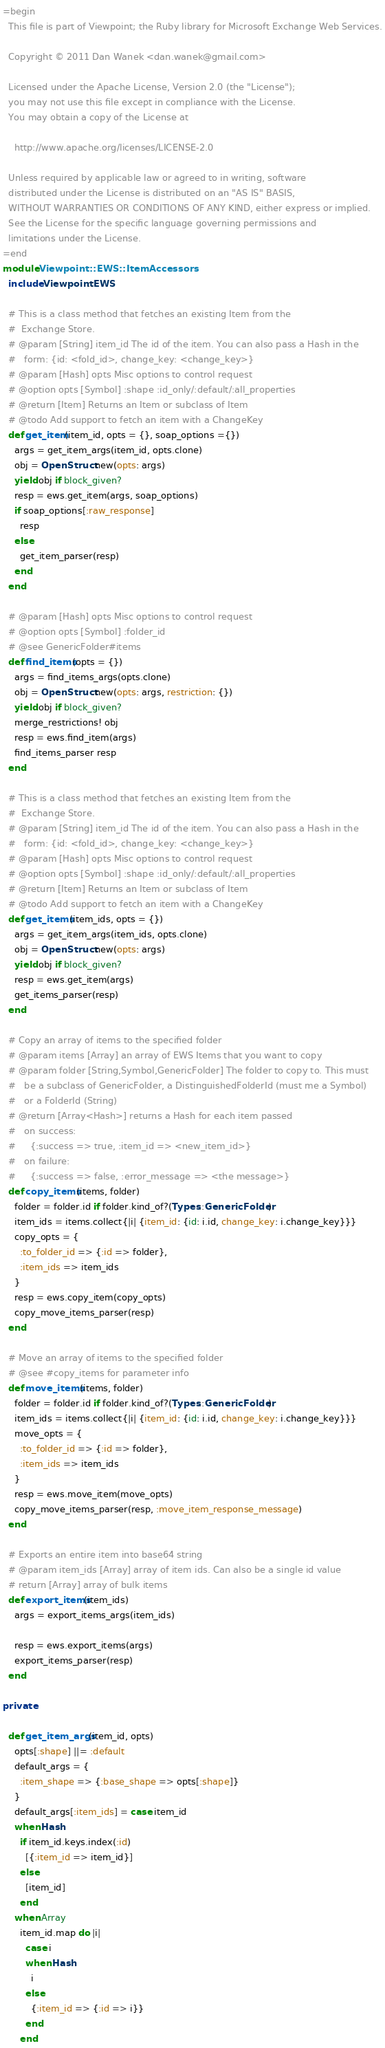<code> <loc_0><loc_0><loc_500><loc_500><_Ruby_>=begin
  This file is part of Viewpoint; the Ruby library for Microsoft Exchange Web Services.

  Copyright © 2011 Dan Wanek <dan.wanek@gmail.com>

  Licensed under the Apache License, Version 2.0 (the "License");
  you may not use this file except in compliance with the License.
  You may obtain a copy of the License at

    http://www.apache.org/licenses/LICENSE-2.0

  Unless required by applicable law or agreed to in writing, software
  distributed under the License is distributed on an "AS IS" BASIS,
  WITHOUT WARRANTIES OR CONDITIONS OF ANY KIND, either express or implied.
  See the License for the specific language governing permissions and
  limitations under the License.
=end
module Viewpoint::EWS::ItemAccessors
  include Viewpoint::EWS

  # This is a class method that fetches an existing Item from the
  #  Exchange Store.
  # @param [String] item_id The id of the item. You can also pass a Hash in the
  #   form: {id: <fold_id>, change_key: <change_key>}
  # @param [Hash] opts Misc options to control request
  # @option opts [Symbol] :shape :id_only/:default/:all_properties
  # @return [Item] Returns an Item or subclass of Item
  # @todo Add support to fetch an item with a ChangeKey
  def get_item(item_id, opts = {}, soap_options ={})
    args = get_item_args(item_id, opts.clone)
    obj = OpenStruct.new(opts: args)
    yield obj if block_given?
    resp = ews.get_item(args, soap_options)
    if soap_options[:raw_response]
      resp
    else
      get_item_parser(resp)
    end
  end

  # @param [Hash] opts Misc options to control request
  # @option opts [Symbol] :folder_id
  # @see GenericFolder#items
  def find_items(opts = {})
    args = find_items_args(opts.clone)
    obj = OpenStruct.new(opts: args, restriction: {})
    yield obj if block_given?
    merge_restrictions! obj
    resp = ews.find_item(args)
    find_items_parser resp
  end

  # This is a class method that fetches an existing Item from the
  #  Exchange Store.
  # @param [String] item_id The id of the item. You can also pass a Hash in the
  #   form: {id: <fold_id>, change_key: <change_key>}
  # @param [Hash] opts Misc options to control request
  # @option opts [Symbol] :shape :id_only/:default/:all_properties
  # @return [Item] Returns an Item or subclass of Item
  # @todo Add support to fetch an item with a ChangeKey
  def get_items(item_ids, opts = {})
    args = get_item_args(item_ids, opts.clone)
    obj = OpenStruct.new(opts: args)
    yield obj if block_given?
    resp = ews.get_item(args)
    get_items_parser(resp)
  end

  # Copy an array of items to the specified folder
  # @param items [Array] an array of EWS Items that you want to copy
  # @param folder [String,Symbol,GenericFolder] The folder to copy to. This must
  #   be a subclass of GenericFolder, a DistinguishedFolderId (must me a Symbol)
  #   or a FolderId (String)
  # @return [Array<Hash>] returns a Hash for each item passed
  #   on success:
  #     {:success => true, :item_id => <new_item_id>}
  #   on failure:
  #     {:success => false, :error_message => <the message>}
  def copy_items(items, folder)
    folder = folder.id if folder.kind_of?(Types::GenericFolder)
    item_ids = items.collect{|i| {item_id: {id: i.id, change_key: i.change_key}}}
    copy_opts = {
      :to_folder_id => {:id => folder},
      :item_ids => item_ids
    }
    resp = ews.copy_item(copy_opts)
    copy_move_items_parser(resp)
  end

  # Move an array of items to the specified folder
  # @see #copy_items for parameter info
  def move_items(items, folder)
    folder = folder.id if folder.kind_of?(Types::GenericFolder)
    item_ids = items.collect{|i| {item_id: {id: i.id, change_key: i.change_key}}}
    move_opts = {
      :to_folder_id => {:id => folder},
      :item_ids => item_ids
    }
    resp = ews.move_item(move_opts)
    copy_move_items_parser(resp, :move_item_response_message)
  end

  # Exports an entire item into base64 string
  # @param item_ids [Array] array of item ids. Can also be a single id value
  # return [Array] array of bulk items
  def export_items(item_ids)
    args = export_items_args(item_ids)

    resp = ews.export_items(args)
    export_items_parser(resp)
  end

private

  def get_item_args(item_id, opts)
    opts[:shape] ||= :default
    default_args = {
      :item_shape => {:base_shape => opts[:shape]}
    }
    default_args[:item_ids] = case item_id
    when Hash
      if item_id.keys.index(:id)
        [{:item_id => item_id}]
      else
        [item_id]
      end
    when Array
      item_id.map do |i|
        case i
        when Hash
          i
        else
          {:item_id => {:id => i}}
        end
      end</code> 